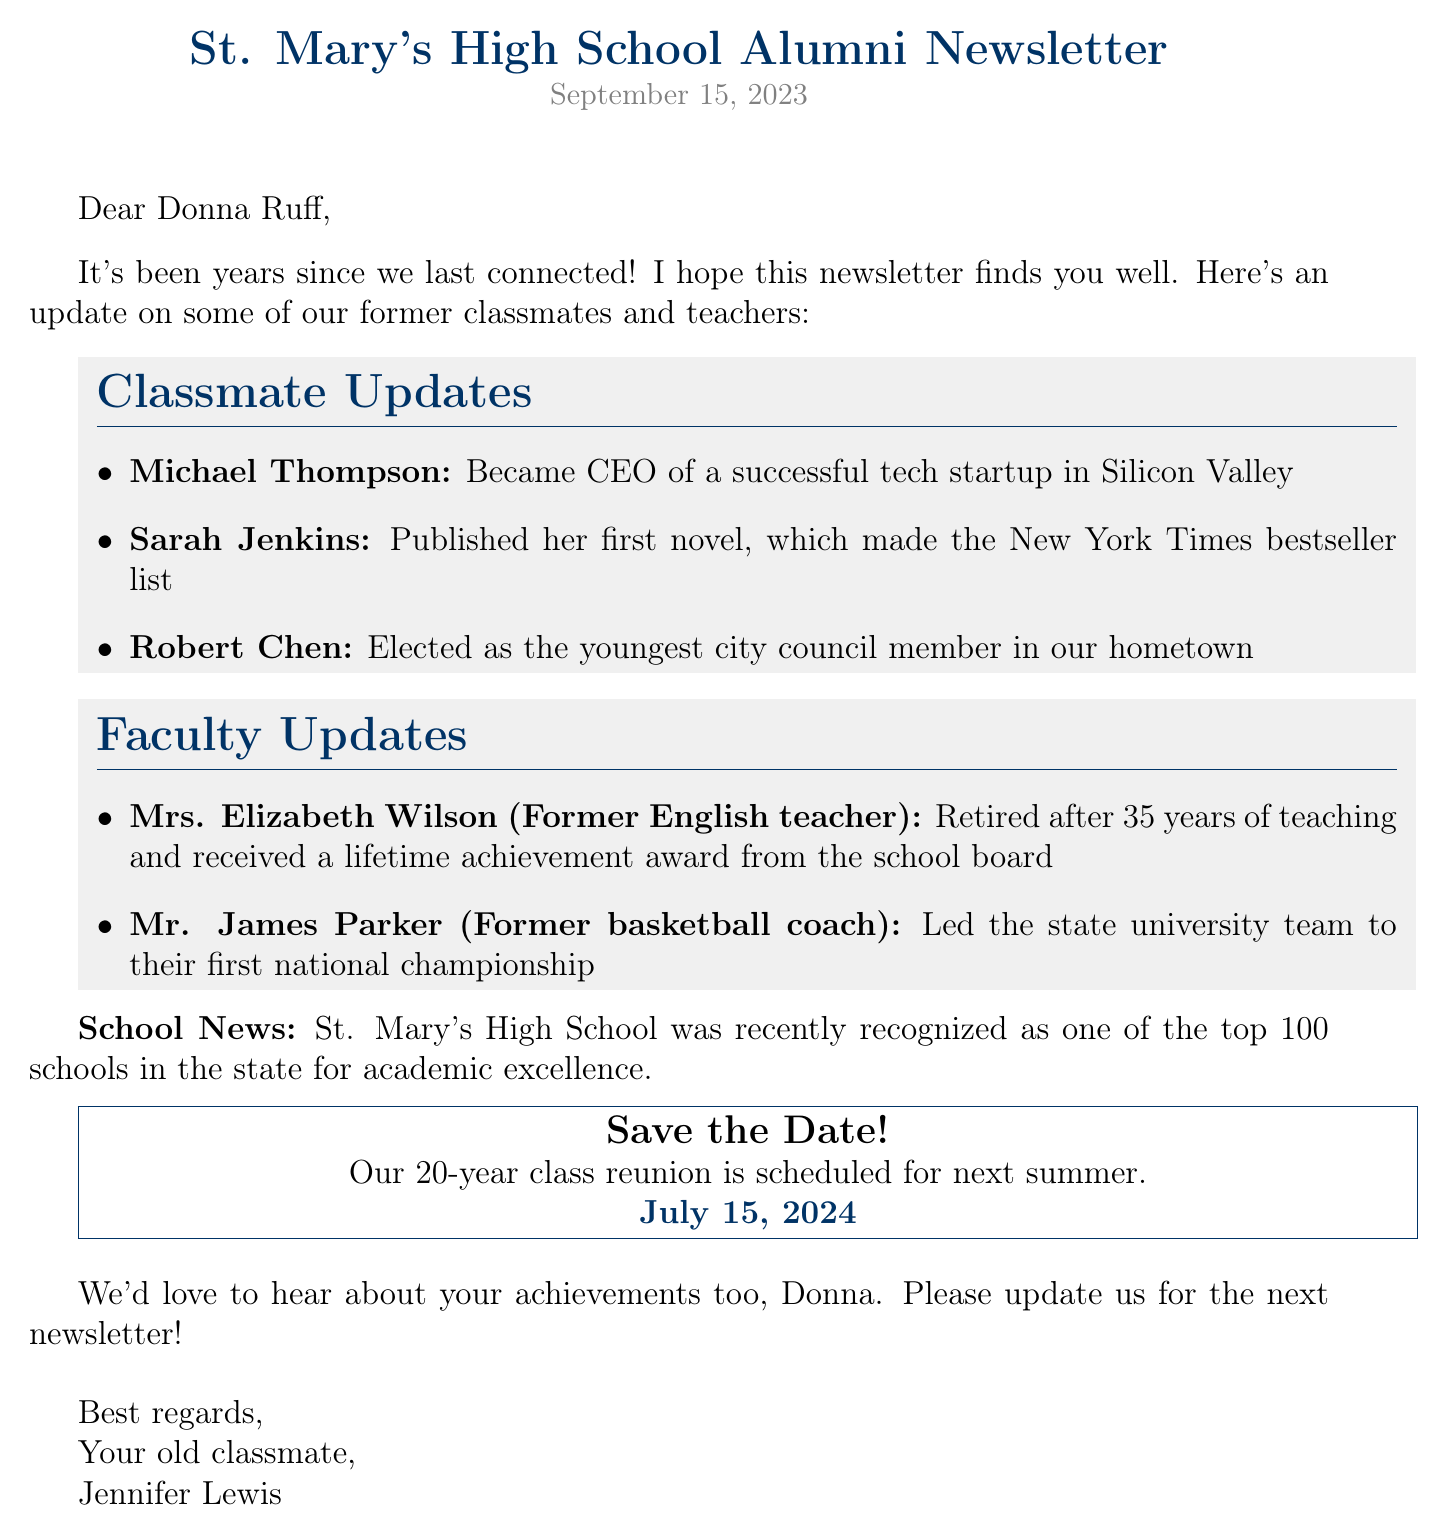What is the publication date of the newsletter? The publication date is clearly stated at the top of the newsletter section.
Answer: September 15, 2023 Who became the CEO of a tech startup? This information can be found in the classmate updates section.
Answer: Michael Thompson Which former teacher received a lifetime achievement award? The lifetime achievement award recipient is mentioned in the faculty updates section.
Answer: Mrs. Elizabeth Wilson What year is the class reunion scheduled for? The reunion date is highlighted and is easy to find in the document.
Answer: July 15, 2024 Who was elected as the youngest city council member? This detail is part of the classmate updates and can be pinpointed easily.
Answer: Robert Chen What is the school's recent achievement? The specific achievement is provided in the school news section of the document.
Answer: Top 100 schools in the state for academic excellence Who led their team to the first national championship? This information is found in the faculty updates section.
Answer: Mr. James Parker What is the main theme of this newsletter? Understanding the context of the newsletter reveals its purpose.
Answer: Alumni achievements 